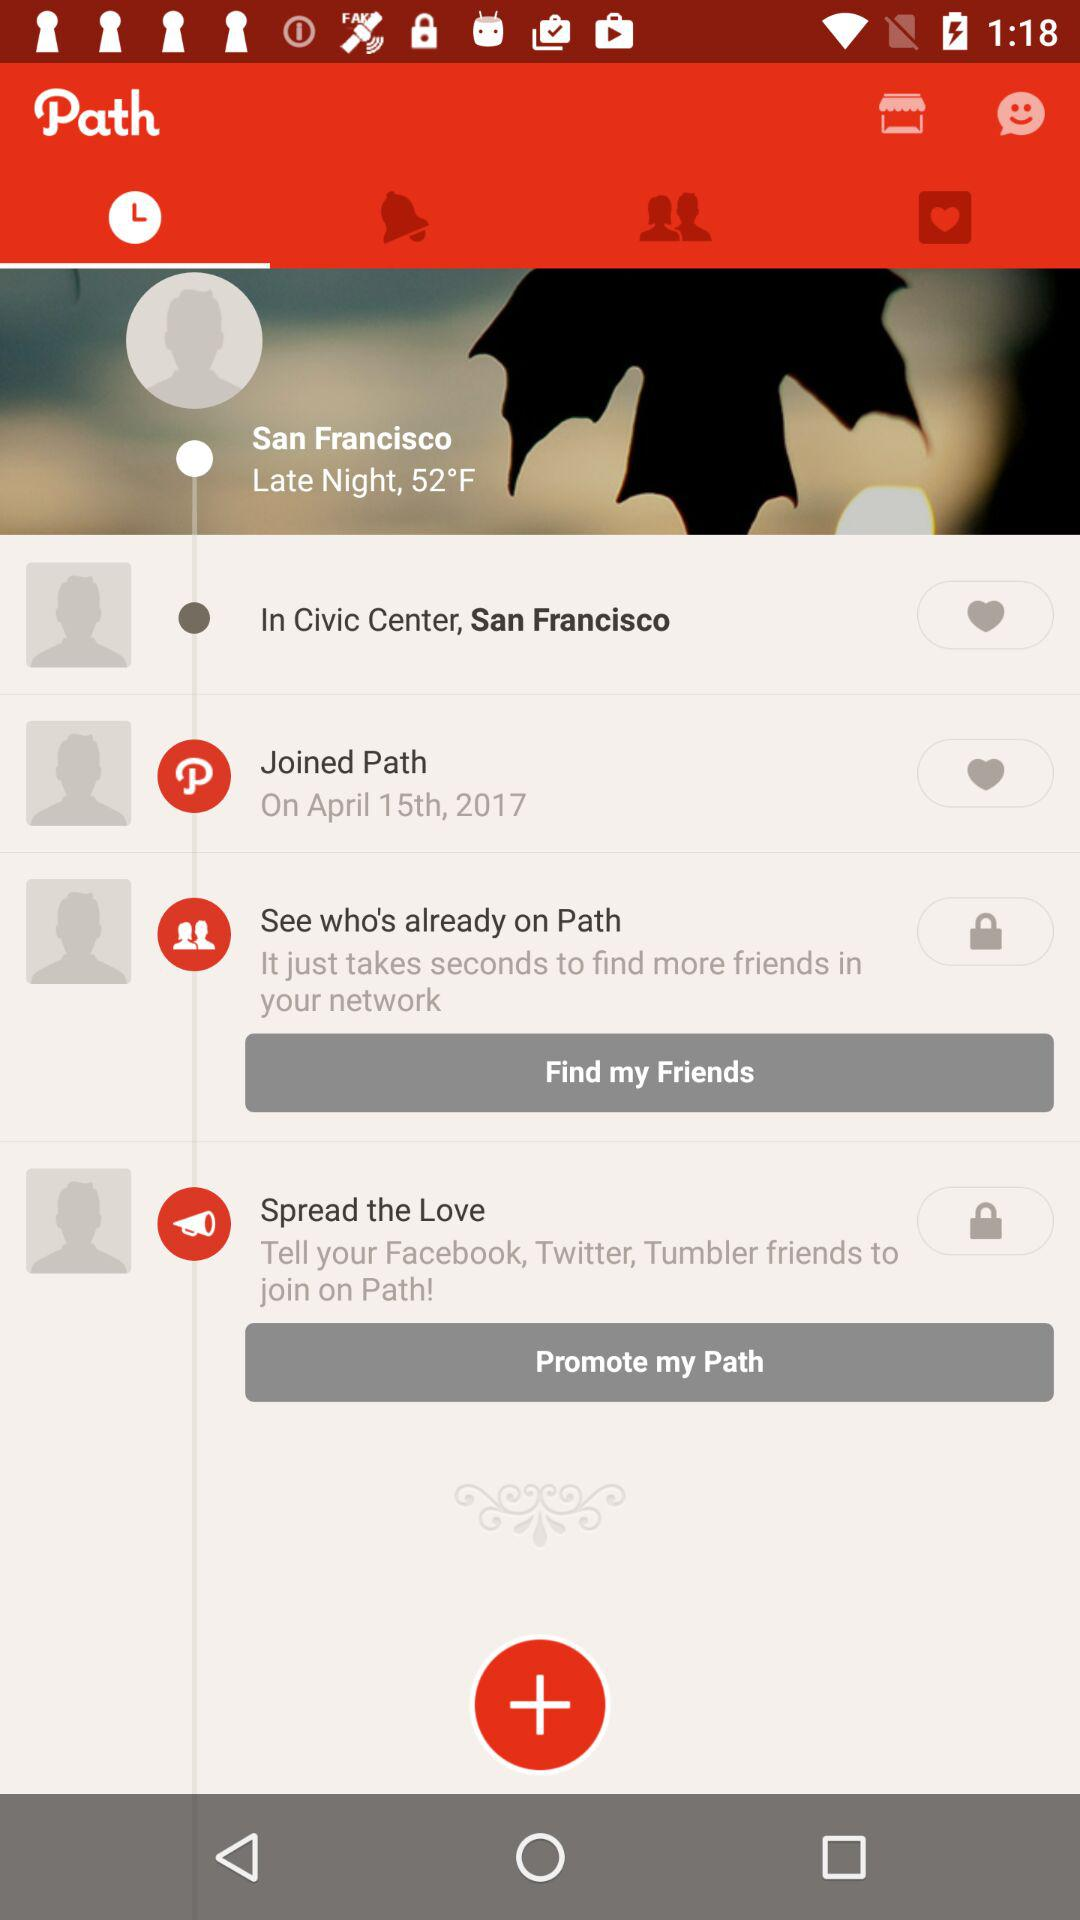What is the location? The location is Civic Center, San Francisco. 